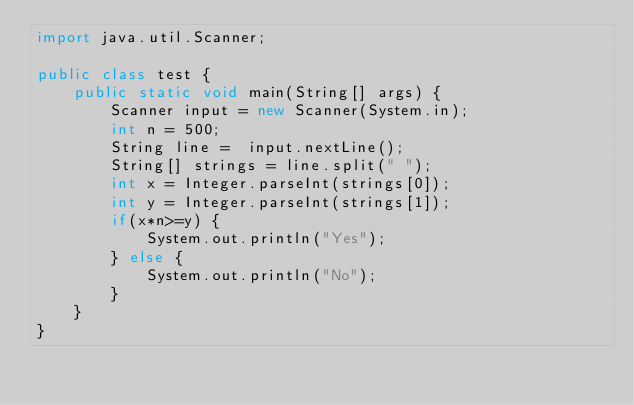Convert code to text. <code><loc_0><loc_0><loc_500><loc_500><_Java_>import java.util.Scanner;

public class test {
    public static void main(String[] args) {
        Scanner input = new Scanner(System.in);
        int n = 500;
        String line =  input.nextLine();
        String[] strings = line.split(" ");
        int x = Integer.parseInt(strings[0]);
        int y = Integer.parseInt(strings[1]);
        if(x*n>=y) {
            System.out.println("Yes");
        } else {
            System.out.println("No");
        }
    }
}
</code> 